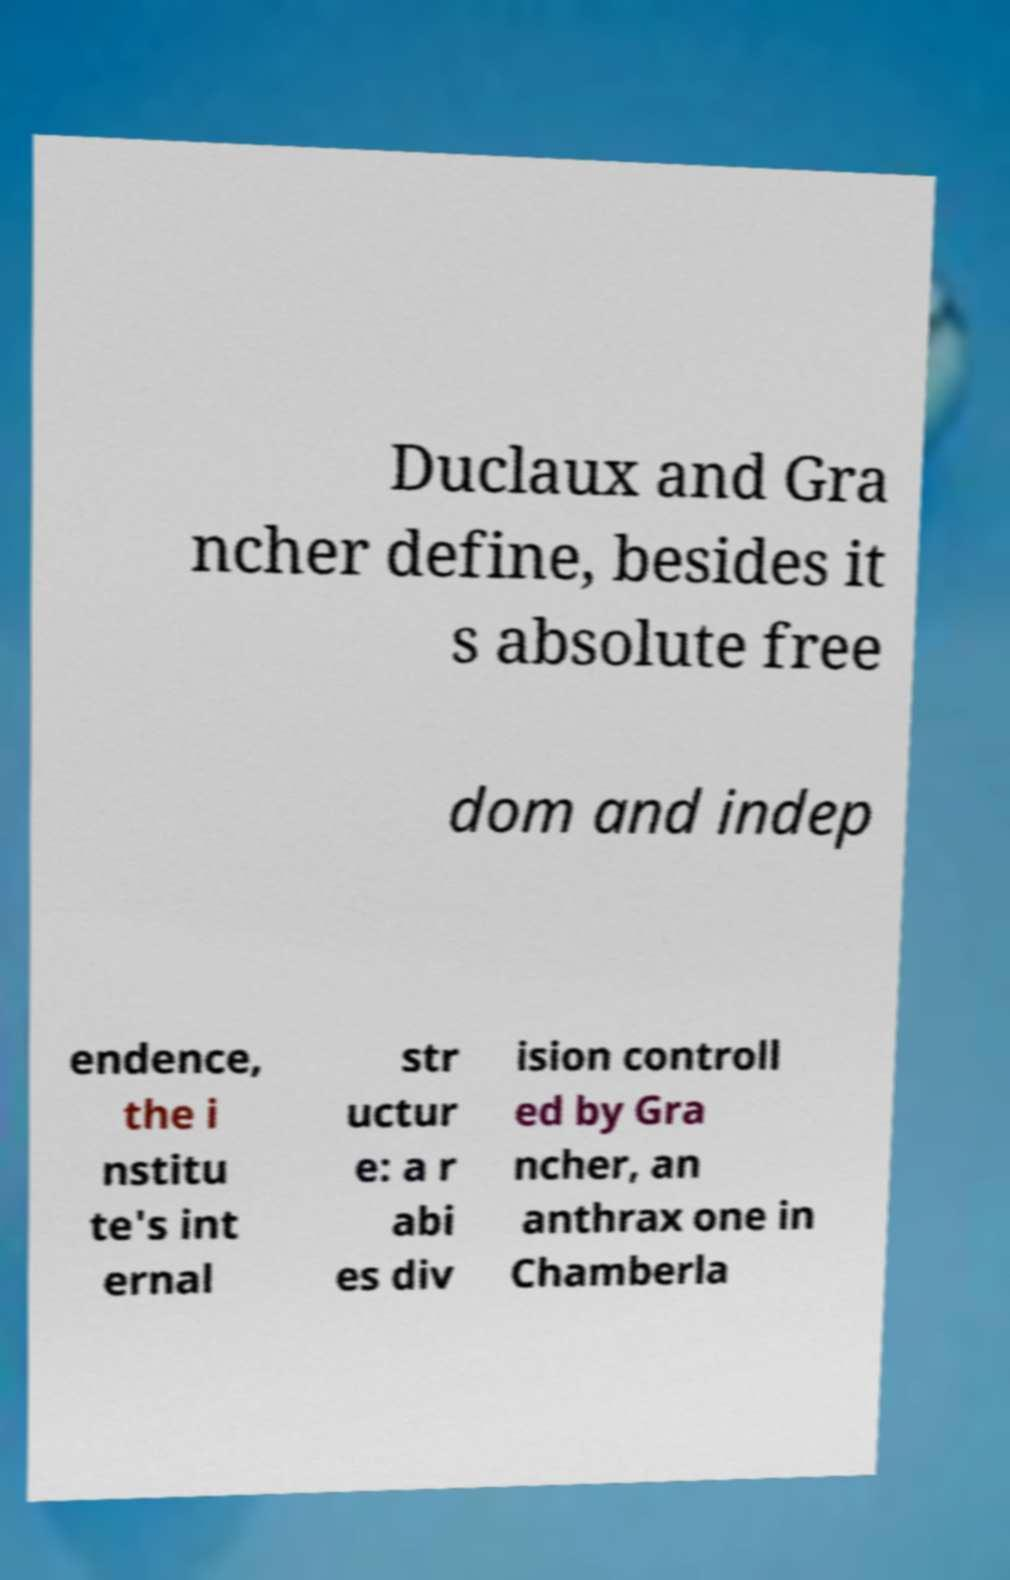Please read and relay the text visible in this image. What does it say? Duclaux and Gra ncher define, besides it s absolute free dom and indep endence, the i nstitu te's int ernal str uctur e: a r abi es div ision controll ed by Gra ncher, an anthrax one in Chamberla 